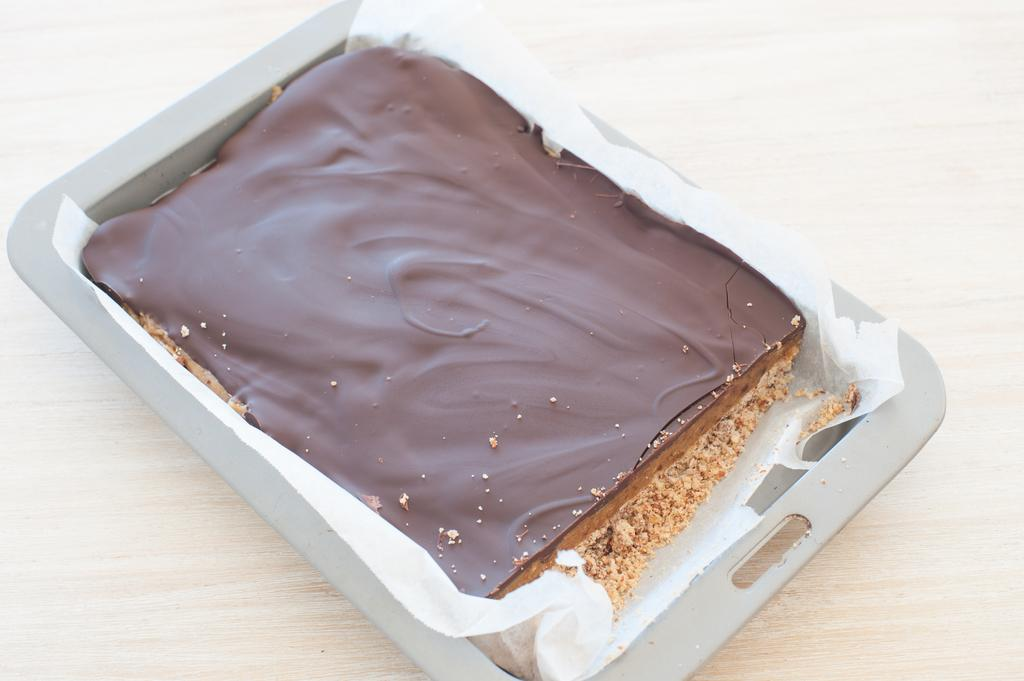What is present on the wooden surface in the image? There is a tray on the wooden surface in the image. What is inside the tray? There is butter paper in the tray. What is placed on the butter paper? There is a cake on the butter paper. Can you tell me how the beggar is being treated in the image? There is no beggar present in the image. Is there a rat visible in the image? There is no rat present in the image. 